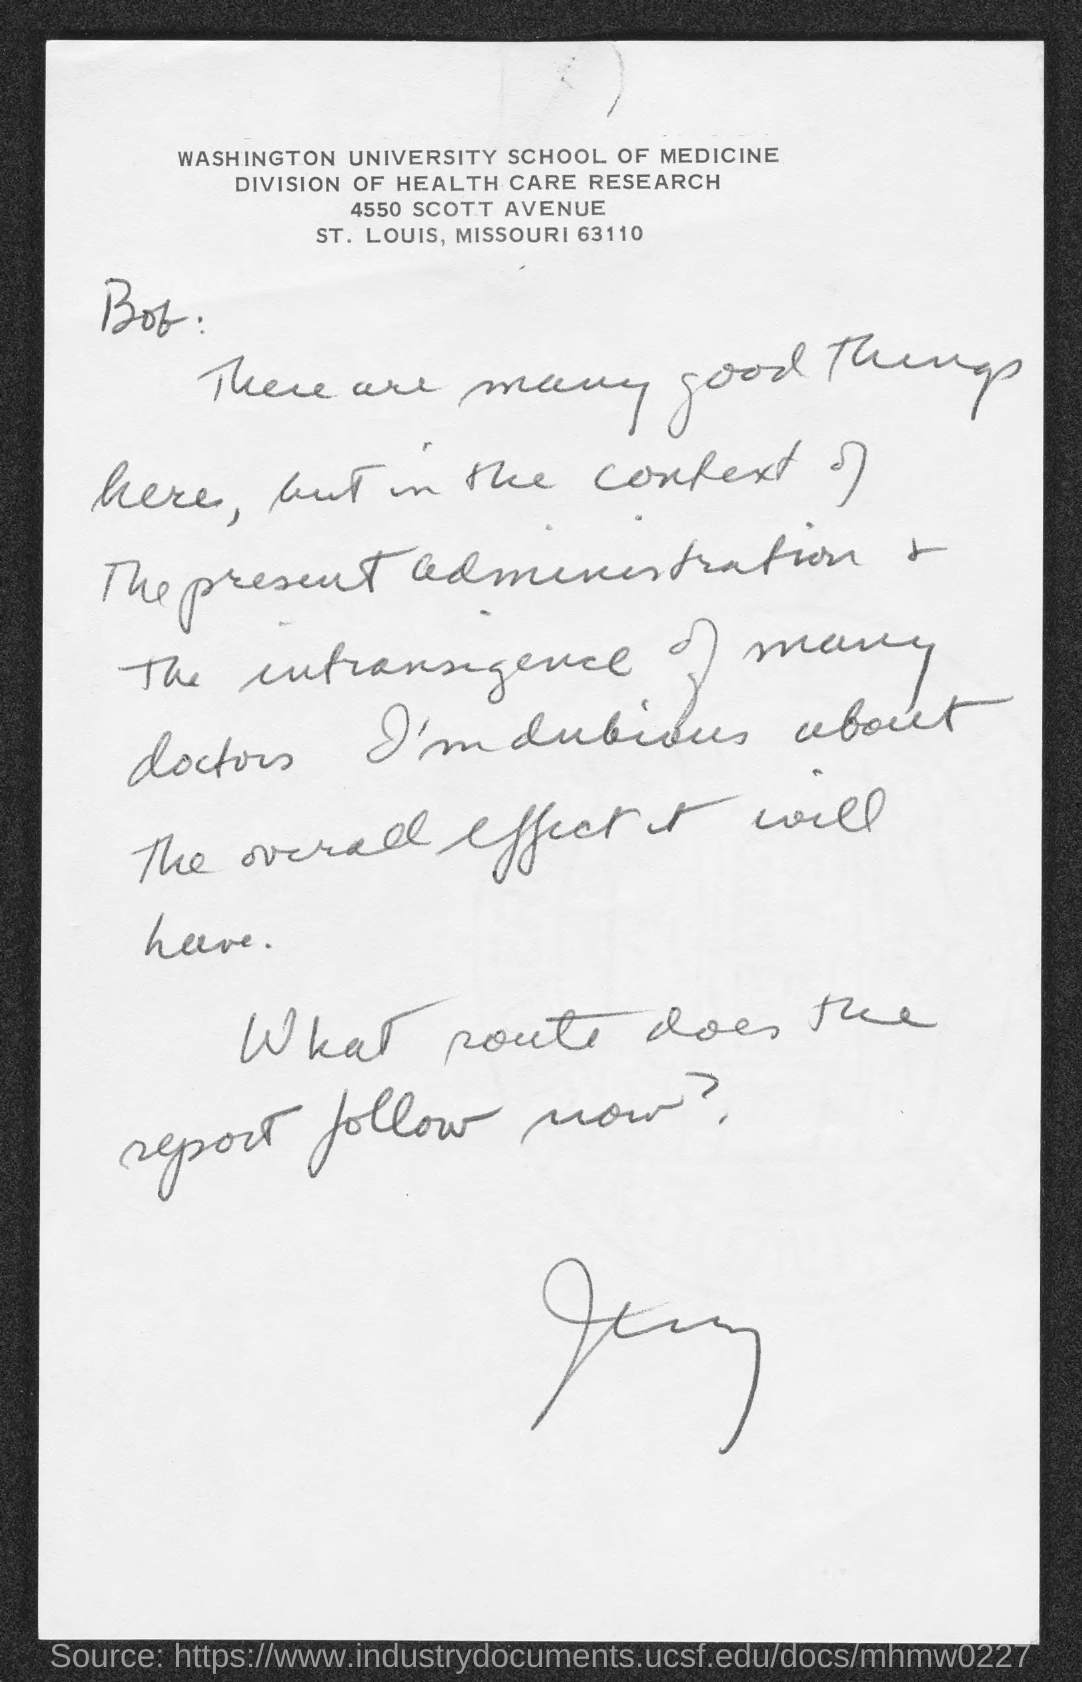Which university is mentioned in the header of the document?
Offer a terse response. Washington University School of Medicine. 